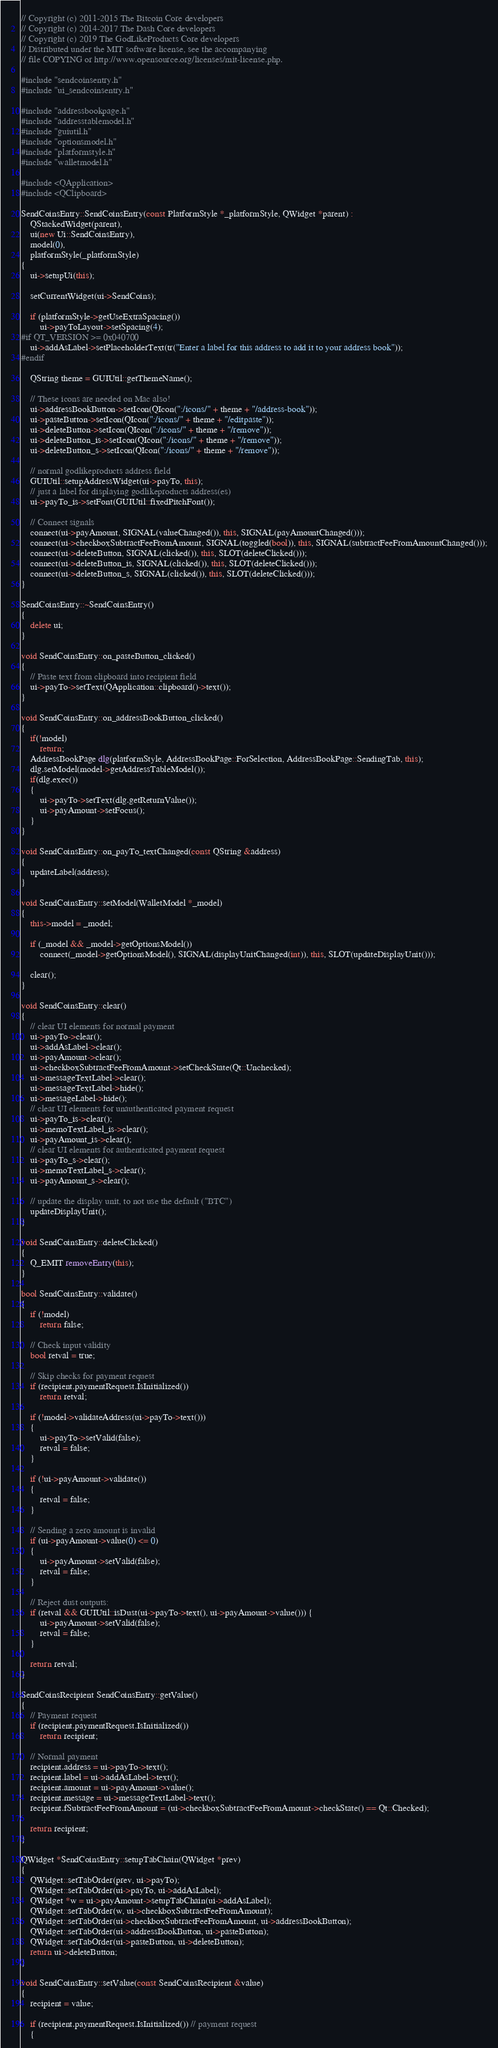<code> <loc_0><loc_0><loc_500><loc_500><_C++_>// Copyright (c) 2011-2015 The Bitcoin Core developers
// Copyright (c) 2014-2017 The Dash Core developers
// Copyright (c) 2019 The GodLikeProducts Core developers
// Distributed under the MIT software license, see the accompanying
// file COPYING or http://www.opensource.org/licenses/mit-license.php.

#include "sendcoinsentry.h"
#include "ui_sendcoinsentry.h"

#include "addressbookpage.h"
#include "addresstablemodel.h"
#include "guiutil.h"
#include "optionsmodel.h"
#include "platformstyle.h"
#include "walletmodel.h"

#include <QApplication>
#include <QClipboard>

SendCoinsEntry::SendCoinsEntry(const PlatformStyle *_platformStyle, QWidget *parent) :
    QStackedWidget(parent),
    ui(new Ui::SendCoinsEntry),
    model(0),
    platformStyle(_platformStyle)
{
    ui->setupUi(this);

    setCurrentWidget(ui->SendCoins);

    if (platformStyle->getUseExtraSpacing())
        ui->payToLayout->setSpacing(4);
#if QT_VERSION >= 0x040700
    ui->addAsLabel->setPlaceholderText(tr("Enter a label for this address to add it to your address book"));
#endif

    QString theme = GUIUtil::getThemeName();

    // These icons are needed on Mac also!
    ui->addressBookButton->setIcon(QIcon(":/icons/" + theme + "/address-book"));
    ui->pasteButton->setIcon(QIcon(":/icons/" + theme + "/editpaste"));
    ui->deleteButton->setIcon(QIcon(":/icons/" + theme + "/remove"));
    ui->deleteButton_is->setIcon(QIcon(":/icons/" + theme + "/remove"));
    ui->deleteButton_s->setIcon(QIcon(":/icons/" + theme + "/remove"));
      
    // normal godlikeproducts address field
    GUIUtil::setupAddressWidget(ui->payTo, this);
    // just a label for displaying godlikeproducts address(es)
    ui->payTo_is->setFont(GUIUtil::fixedPitchFont());

    // Connect signals
    connect(ui->payAmount, SIGNAL(valueChanged()), this, SIGNAL(payAmountChanged()));
    connect(ui->checkboxSubtractFeeFromAmount, SIGNAL(toggled(bool)), this, SIGNAL(subtractFeeFromAmountChanged()));
    connect(ui->deleteButton, SIGNAL(clicked()), this, SLOT(deleteClicked()));
    connect(ui->deleteButton_is, SIGNAL(clicked()), this, SLOT(deleteClicked()));
    connect(ui->deleteButton_s, SIGNAL(clicked()), this, SLOT(deleteClicked()));
}

SendCoinsEntry::~SendCoinsEntry()
{
    delete ui;
}

void SendCoinsEntry::on_pasteButton_clicked()
{
    // Paste text from clipboard into recipient field
    ui->payTo->setText(QApplication::clipboard()->text());
}

void SendCoinsEntry::on_addressBookButton_clicked()
{
    if(!model)
        return;
    AddressBookPage dlg(platformStyle, AddressBookPage::ForSelection, AddressBookPage::SendingTab, this);
    dlg.setModel(model->getAddressTableModel());
    if(dlg.exec())
    {
        ui->payTo->setText(dlg.getReturnValue());
        ui->payAmount->setFocus();
    }
}

void SendCoinsEntry::on_payTo_textChanged(const QString &address)
{
    updateLabel(address);
}

void SendCoinsEntry::setModel(WalletModel *_model)
{
    this->model = _model;

    if (_model && _model->getOptionsModel())
        connect(_model->getOptionsModel(), SIGNAL(displayUnitChanged(int)), this, SLOT(updateDisplayUnit()));

    clear();
}

void SendCoinsEntry::clear()
{
    // clear UI elements for normal payment
    ui->payTo->clear();
    ui->addAsLabel->clear();
    ui->payAmount->clear();
    ui->checkboxSubtractFeeFromAmount->setCheckState(Qt::Unchecked);
    ui->messageTextLabel->clear();
    ui->messageTextLabel->hide();
    ui->messageLabel->hide();
    // clear UI elements for unauthenticated payment request
    ui->payTo_is->clear();
    ui->memoTextLabel_is->clear();
    ui->payAmount_is->clear();
    // clear UI elements for authenticated payment request
    ui->payTo_s->clear();
    ui->memoTextLabel_s->clear();
    ui->payAmount_s->clear();

    // update the display unit, to not use the default ("BTC")
    updateDisplayUnit();
}

void SendCoinsEntry::deleteClicked()
{
    Q_EMIT removeEntry(this);
}

bool SendCoinsEntry::validate()
{
    if (!model)
        return false;

    // Check input validity
    bool retval = true;

    // Skip checks for payment request
    if (recipient.paymentRequest.IsInitialized())
        return retval;

    if (!model->validateAddress(ui->payTo->text()))
    {
        ui->payTo->setValid(false);
        retval = false;
    }

    if (!ui->payAmount->validate())
    {
        retval = false;
    }

    // Sending a zero amount is invalid
    if (ui->payAmount->value(0) <= 0)
    {
        ui->payAmount->setValid(false);
        retval = false;
    }

    // Reject dust outputs:
    if (retval && GUIUtil::isDust(ui->payTo->text(), ui->payAmount->value())) {
        ui->payAmount->setValid(false);
        retval = false;
    }

    return retval;
}

SendCoinsRecipient SendCoinsEntry::getValue()
{
    // Payment request
    if (recipient.paymentRequest.IsInitialized())
        return recipient;

    // Normal payment
    recipient.address = ui->payTo->text();
    recipient.label = ui->addAsLabel->text();
    recipient.amount = ui->payAmount->value();
    recipient.message = ui->messageTextLabel->text();
    recipient.fSubtractFeeFromAmount = (ui->checkboxSubtractFeeFromAmount->checkState() == Qt::Checked);

    return recipient;
}

QWidget *SendCoinsEntry::setupTabChain(QWidget *prev)
{
    QWidget::setTabOrder(prev, ui->payTo);
    QWidget::setTabOrder(ui->payTo, ui->addAsLabel);
    QWidget *w = ui->payAmount->setupTabChain(ui->addAsLabel);
    QWidget::setTabOrder(w, ui->checkboxSubtractFeeFromAmount);
    QWidget::setTabOrder(ui->checkboxSubtractFeeFromAmount, ui->addressBookButton);
    QWidget::setTabOrder(ui->addressBookButton, ui->pasteButton);
    QWidget::setTabOrder(ui->pasteButton, ui->deleteButton);
    return ui->deleteButton;
}

void SendCoinsEntry::setValue(const SendCoinsRecipient &value)
{
    recipient = value;

    if (recipient.paymentRequest.IsInitialized()) // payment request
    {</code> 